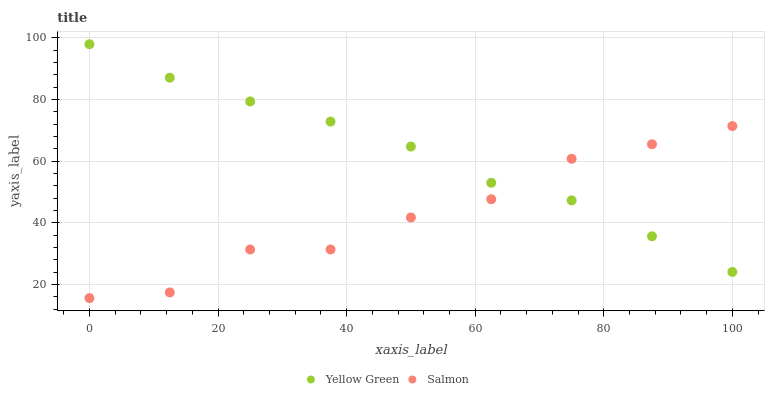Does Salmon have the minimum area under the curve?
Answer yes or no. Yes. Does Yellow Green have the maximum area under the curve?
Answer yes or no. Yes. Does Yellow Green have the minimum area under the curve?
Answer yes or no. No. Is Yellow Green the smoothest?
Answer yes or no. Yes. Is Salmon the roughest?
Answer yes or no. Yes. Is Yellow Green the roughest?
Answer yes or no. No. Does Salmon have the lowest value?
Answer yes or no. Yes. Does Yellow Green have the lowest value?
Answer yes or no. No. Does Yellow Green have the highest value?
Answer yes or no. Yes. Does Salmon intersect Yellow Green?
Answer yes or no. Yes. Is Salmon less than Yellow Green?
Answer yes or no. No. Is Salmon greater than Yellow Green?
Answer yes or no. No. 